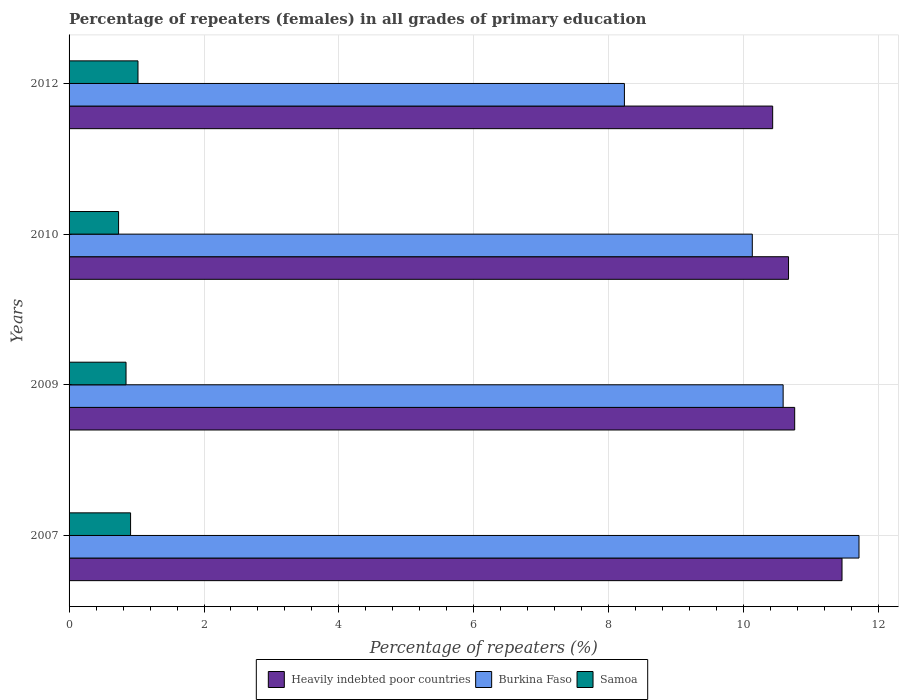How many different coloured bars are there?
Keep it short and to the point. 3. How many groups of bars are there?
Offer a very short reply. 4. Are the number of bars per tick equal to the number of legend labels?
Keep it short and to the point. Yes. Are the number of bars on each tick of the Y-axis equal?
Your answer should be very brief. Yes. What is the label of the 4th group of bars from the top?
Your response must be concise. 2007. What is the percentage of repeaters (females) in Heavily indebted poor countries in 2007?
Ensure brevity in your answer.  11.46. Across all years, what is the maximum percentage of repeaters (females) in Heavily indebted poor countries?
Provide a succinct answer. 11.46. Across all years, what is the minimum percentage of repeaters (females) in Heavily indebted poor countries?
Keep it short and to the point. 10.43. In which year was the percentage of repeaters (females) in Heavily indebted poor countries maximum?
Offer a terse response. 2007. What is the total percentage of repeaters (females) in Heavily indebted poor countries in the graph?
Your answer should be very brief. 43.3. What is the difference between the percentage of repeaters (females) in Heavily indebted poor countries in 2007 and that in 2009?
Your response must be concise. 0.7. What is the difference between the percentage of repeaters (females) in Samoa in 2009 and the percentage of repeaters (females) in Heavily indebted poor countries in 2012?
Keep it short and to the point. -9.58. What is the average percentage of repeaters (females) in Samoa per year?
Offer a very short reply. 0.88. In the year 2009, what is the difference between the percentage of repeaters (females) in Burkina Faso and percentage of repeaters (females) in Heavily indebted poor countries?
Keep it short and to the point. -0.17. In how many years, is the percentage of repeaters (females) in Samoa greater than 4 %?
Provide a succinct answer. 0. What is the ratio of the percentage of repeaters (females) in Burkina Faso in 2010 to that in 2012?
Keep it short and to the point. 1.23. What is the difference between the highest and the second highest percentage of repeaters (females) in Samoa?
Offer a terse response. 0.11. What is the difference between the highest and the lowest percentage of repeaters (females) in Samoa?
Give a very brief answer. 0.29. In how many years, is the percentage of repeaters (females) in Samoa greater than the average percentage of repeaters (females) in Samoa taken over all years?
Your response must be concise. 2. What does the 1st bar from the top in 2007 represents?
Give a very brief answer. Samoa. What does the 1st bar from the bottom in 2012 represents?
Your answer should be very brief. Heavily indebted poor countries. Is it the case that in every year, the sum of the percentage of repeaters (females) in Samoa and percentage of repeaters (females) in Burkina Faso is greater than the percentage of repeaters (females) in Heavily indebted poor countries?
Make the answer very short. No. Are all the bars in the graph horizontal?
Make the answer very short. Yes. How many years are there in the graph?
Provide a succinct answer. 4. What is the difference between two consecutive major ticks on the X-axis?
Keep it short and to the point. 2. Are the values on the major ticks of X-axis written in scientific E-notation?
Make the answer very short. No. Does the graph contain grids?
Your response must be concise. Yes. Where does the legend appear in the graph?
Provide a short and direct response. Bottom center. How are the legend labels stacked?
Your answer should be compact. Horizontal. What is the title of the graph?
Ensure brevity in your answer.  Percentage of repeaters (females) in all grades of primary education. What is the label or title of the X-axis?
Give a very brief answer. Percentage of repeaters (%). What is the Percentage of repeaters (%) in Heavily indebted poor countries in 2007?
Offer a terse response. 11.46. What is the Percentage of repeaters (%) of Burkina Faso in 2007?
Your answer should be compact. 11.71. What is the Percentage of repeaters (%) in Samoa in 2007?
Provide a short and direct response. 0.91. What is the Percentage of repeaters (%) of Heavily indebted poor countries in 2009?
Your answer should be very brief. 10.76. What is the Percentage of repeaters (%) of Burkina Faso in 2009?
Your answer should be very brief. 10.58. What is the Percentage of repeaters (%) in Samoa in 2009?
Keep it short and to the point. 0.84. What is the Percentage of repeaters (%) of Heavily indebted poor countries in 2010?
Your response must be concise. 10.66. What is the Percentage of repeaters (%) in Burkina Faso in 2010?
Give a very brief answer. 10.13. What is the Percentage of repeaters (%) in Samoa in 2010?
Give a very brief answer. 0.73. What is the Percentage of repeaters (%) in Heavily indebted poor countries in 2012?
Give a very brief answer. 10.43. What is the Percentage of repeaters (%) in Burkina Faso in 2012?
Your answer should be compact. 8.23. What is the Percentage of repeaters (%) of Samoa in 2012?
Offer a terse response. 1.02. Across all years, what is the maximum Percentage of repeaters (%) of Heavily indebted poor countries?
Your answer should be compact. 11.46. Across all years, what is the maximum Percentage of repeaters (%) in Burkina Faso?
Your answer should be very brief. 11.71. Across all years, what is the maximum Percentage of repeaters (%) in Samoa?
Keep it short and to the point. 1.02. Across all years, what is the minimum Percentage of repeaters (%) of Heavily indebted poor countries?
Give a very brief answer. 10.43. Across all years, what is the minimum Percentage of repeaters (%) in Burkina Faso?
Keep it short and to the point. 8.23. Across all years, what is the minimum Percentage of repeaters (%) of Samoa?
Keep it short and to the point. 0.73. What is the total Percentage of repeaters (%) in Heavily indebted poor countries in the graph?
Your answer should be compact. 43.3. What is the total Percentage of repeaters (%) in Burkina Faso in the graph?
Offer a very short reply. 40.65. What is the total Percentage of repeaters (%) in Samoa in the graph?
Make the answer very short. 3.51. What is the difference between the Percentage of repeaters (%) of Heavily indebted poor countries in 2007 and that in 2009?
Give a very brief answer. 0.7. What is the difference between the Percentage of repeaters (%) of Burkina Faso in 2007 and that in 2009?
Offer a very short reply. 1.12. What is the difference between the Percentage of repeaters (%) of Samoa in 2007 and that in 2009?
Offer a very short reply. 0.07. What is the difference between the Percentage of repeaters (%) of Heavily indebted poor countries in 2007 and that in 2010?
Your answer should be compact. 0.79. What is the difference between the Percentage of repeaters (%) in Burkina Faso in 2007 and that in 2010?
Offer a very short reply. 1.58. What is the difference between the Percentage of repeaters (%) of Samoa in 2007 and that in 2010?
Your answer should be compact. 0.18. What is the difference between the Percentage of repeaters (%) of Heavily indebted poor countries in 2007 and that in 2012?
Provide a succinct answer. 1.03. What is the difference between the Percentage of repeaters (%) in Burkina Faso in 2007 and that in 2012?
Offer a terse response. 3.48. What is the difference between the Percentage of repeaters (%) of Samoa in 2007 and that in 2012?
Ensure brevity in your answer.  -0.11. What is the difference between the Percentage of repeaters (%) of Heavily indebted poor countries in 2009 and that in 2010?
Offer a very short reply. 0.09. What is the difference between the Percentage of repeaters (%) of Burkina Faso in 2009 and that in 2010?
Give a very brief answer. 0.46. What is the difference between the Percentage of repeaters (%) in Samoa in 2009 and that in 2010?
Provide a short and direct response. 0.11. What is the difference between the Percentage of repeaters (%) of Heavily indebted poor countries in 2009 and that in 2012?
Provide a short and direct response. 0.33. What is the difference between the Percentage of repeaters (%) of Burkina Faso in 2009 and that in 2012?
Offer a terse response. 2.35. What is the difference between the Percentage of repeaters (%) in Samoa in 2009 and that in 2012?
Offer a terse response. -0.18. What is the difference between the Percentage of repeaters (%) in Heavily indebted poor countries in 2010 and that in 2012?
Offer a very short reply. 0.23. What is the difference between the Percentage of repeaters (%) in Burkina Faso in 2010 and that in 2012?
Offer a very short reply. 1.9. What is the difference between the Percentage of repeaters (%) in Samoa in 2010 and that in 2012?
Keep it short and to the point. -0.29. What is the difference between the Percentage of repeaters (%) of Heavily indebted poor countries in 2007 and the Percentage of repeaters (%) of Burkina Faso in 2009?
Provide a short and direct response. 0.87. What is the difference between the Percentage of repeaters (%) in Heavily indebted poor countries in 2007 and the Percentage of repeaters (%) in Samoa in 2009?
Make the answer very short. 10.61. What is the difference between the Percentage of repeaters (%) in Burkina Faso in 2007 and the Percentage of repeaters (%) in Samoa in 2009?
Your answer should be compact. 10.86. What is the difference between the Percentage of repeaters (%) of Heavily indebted poor countries in 2007 and the Percentage of repeaters (%) of Burkina Faso in 2010?
Make the answer very short. 1.33. What is the difference between the Percentage of repeaters (%) of Heavily indebted poor countries in 2007 and the Percentage of repeaters (%) of Samoa in 2010?
Your response must be concise. 10.72. What is the difference between the Percentage of repeaters (%) in Burkina Faso in 2007 and the Percentage of repeaters (%) in Samoa in 2010?
Keep it short and to the point. 10.97. What is the difference between the Percentage of repeaters (%) in Heavily indebted poor countries in 2007 and the Percentage of repeaters (%) in Burkina Faso in 2012?
Your answer should be compact. 3.23. What is the difference between the Percentage of repeaters (%) of Heavily indebted poor countries in 2007 and the Percentage of repeaters (%) of Samoa in 2012?
Provide a succinct answer. 10.44. What is the difference between the Percentage of repeaters (%) of Burkina Faso in 2007 and the Percentage of repeaters (%) of Samoa in 2012?
Keep it short and to the point. 10.69. What is the difference between the Percentage of repeaters (%) of Heavily indebted poor countries in 2009 and the Percentage of repeaters (%) of Burkina Faso in 2010?
Provide a short and direct response. 0.63. What is the difference between the Percentage of repeaters (%) in Heavily indebted poor countries in 2009 and the Percentage of repeaters (%) in Samoa in 2010?
Your response must be concise. 10.02. What is the difference between the Percentage of repeaters (%) in Burkina Faso in 2009 and the Percentage of repeaters (%) in Samoa in 2010?
Ensure brevity in your answer.  9.85. What is the difference between the Percentage of repeaters (%) in Heavily indebted poor countries in 2009 and the Percentage of repeaters (%) in Burkina Faso in 2012?
Make the answer very short. 2.52. What is the difference between the Percentage of repeaters (%) in Heavily indebted poor countries in 2009 and the Percentage of repeaters (%) in Samoa in 2012?
Keep it short and to the point. 9.73. What is the difference between the Percentage of repeaters (%) in Burkina Faso in 2009 and the Percentage of repeaters (%) in Samoa in 2012?
Your response must be concise. 9.56. What is the difference between the Percentage of repeaters (%) in Heavily indebted poor countries in 2010 and the Percentage of repeaters (%) in Burkina Faso in 2012?
Give a very brief answer. 2.43. What is the difference between the Percentage of repeaters (%) of Heavily indebted poor countries in 2010 and the Percentage of repeaters (%) of Samoa in 2012?
Give a very brief answer. 9.64. What is the difference between the Percentage of repeaters (%) of Burkina Faso in 2010 and the Percentage of repeaters (%) of Samoa in 2012?
Provide a succinct answer. 9.11. What is the average Percentage of repeaters (%) in Heavily indebted poor countries per year?
Make the answer very short. 10.83. What is the average Percentage of repeaters (%) in Burkina Faso per year?
Make the answer very short. 10.16. What is the average Percentage of repeaters (%) of Samoa per year?
Offer a terse response. 0.88. In the year 2007, what is the difference between the Percentage of repeaters (%) of Heavily indebted poor countries and Percentage of repeaters (%) of Burkina Faso?
Offer a very short reply. -0.25. In the year 2007, what is the difference between the Percentage of repeaters (%) of Heavily indebted poor countries and Percentage of repeaters (%) of Samoa?
Provide a short and direct response. 10.54. In the year 2007, what is the difference between the Percentage of repeaters (%) of Burkina Faso and Percentage of repeaters (%) of Samoa?
Your response must be concise. 10.8. In the year 2009, what is the difference between the Percentage of repeaters (%) of Heavily indebted poor countries and Percentage of repeaters (%) of Burkina Faso?
Ensure brevity in your answer.  0.17. In the year 2009, what is the difference between the Percentage of repeaters (%) of Heavily indebted poor countries and Percentage of repeaters (%) of Samoa?
Provide a succinct answer. 9.91. In the year 2009, what is the difference between the Percentage of repeaters (%) in Burkina Faso and Percentage of repeaters (%) in Samoa?
Your answer should be compact. 9.74. In the year 2010, what is the difference between the Percentage of repeaters (%) in Heavily indebted poor countries and Percentage of repeaters (%) in Burkina Faso?
Offer a terse response. 0.54. In the year 2010, what is the difference between the Percentage of repeaters (%) in Heavily indebted poor countries and Percentage of repeaters (%) in Samoa?
Your answer should be very brief. 9.93. In the year 2010, what is the difference between the Percentage of repeaters (%) in Burkina Faso and Percentage of repeaters (%) in Samoa?
Your response must be concise. 9.39. In the year 2012, what is the difference between the Percentage of repeaters (%) in Heavily indebted poor countries and Percentage of repeaters (%) in Burkina Faso?
Your answer should be compact. 2.2. In the year 2012, what is the difference between the Percentage of repeaters (%) in Heavily indebted poor countries and Percentage of repeaters (%) in Samoa?
Give a very brief answer. 9.41. In the year 2012, what is the difference between the Percentage of repeaters (%) in Burkina Faso and Percentage of repeaters (%) in Samoa?
Provide a succinct answer. 7.21. What is the ratio of the Percentage of repeaters (%) in Heavily indebted poor countries in 2007 to that in 2009?
Your answer should be compact. 1.07. What is the ratio of the Percentage of repeaters (%) in Burkina Faso in 2007 to that in 2009?
Your response must be concise. 1.11. What is the ratio of the Percentage of repeaters (%) of Samoa in 2007 to that in 2009?
Keep it short and to the point. 1.08. What is the ratio of the Percentage of repeaters (%) in Heavily indebted poor countries in 2007 to that in 2010?
Give a very brief answer. 1.07. What is the ratio of the Percentage of repeaters (%) of Burkina Faso in 2007 to that in 2010?
Keep it short and to the point. 1.16. What is the ratio of the Percentage of repeaters (%) in Samoa in 2007 to that in 2010?
Offer a terse response. 1.24. What is the ratio of the Percentage of repeaters (%) of Heavily indebted poor countries in 2007 to that in 2012?
Your response must be concise. 1.1. What is the ratio of the Percentage of repeaters (%) of Burkina Faso in 2007 to that in 2012?
Your answer should be compact. 1.42. What is the ratio of the Percentage of repeaters (%) in Samoa in 2007 to that in 2012?
Your answer should be very brief. 0.89. What is the ratio of the Percentage of repeaters (%) in Heavily indebted poor countries in 2009 to that in 2010?
Give a very brief answer. 1.01. What is the ratio of the Percentage of repeaters (%) of Burkina Faso in 2009 to that in 2010?
Ensure brevity in your answer.  1.05. What is the ratio of the Percentage of repeaters (%) of Samoa in 2009 to that in 2010?
Your response must be concise. 1.15. What is the ratio of the Percentage of repeaters (%) of Heavily indebted poor countries in 2009 to that in 2012?
Give a very brief answer. 1.03. What is the ratio of the Percentage of repeaters (%) in Burkina Faso in 2009 to that in 2012?
Your answer should be compact. 1.29. What is the ratio of the Percentage of repeaters (%) in Samoa in 2009 to that in 2012?
Make the answer very short. 0.83. What is the ratio of the Percentage of repeaters (%) in Heavily indebted poor countries in 2010 to that in 2012?
Provide a short and direct response. 1.02. What is the ratio of the Percentage of repeaters (%) of Burkina Faso in 2010 to that in 2012?
Ensure brevity in your answer.  1.23. What is the ratio of the Percentage of repeaters (%) in Samoa in 2010 to that in 2012?
Your answer should be very brief. 0.72. What is the difference between the highest and the second highest Percentage of repeaters (%) of Heavily indebted poor countries?
Provide a short and direct response. 0.7. What is the difference between the highest and the second highest Percentage of repeaters (%) of Burkina Faso?
Provide a short and direct response. 1.12. What is the difference between the highest and the second highest Percentage of repeaters (%) of Samoa?
Your response must be concise. 0.11. What is the difference between the highest and the lowest Percentage of repeaters (%) in Heavily indebted poor countries?
Provide a succinct answer. 1.03. What is the difference between the highest and the lowest Percentage of repeaters (%) of Burkina Faso?
Make the answer very short. 3.48. What is the difference between the highest and the lowest Percentage of repeaters (%) in Samoa?
Offer a terse response. 0.29. 